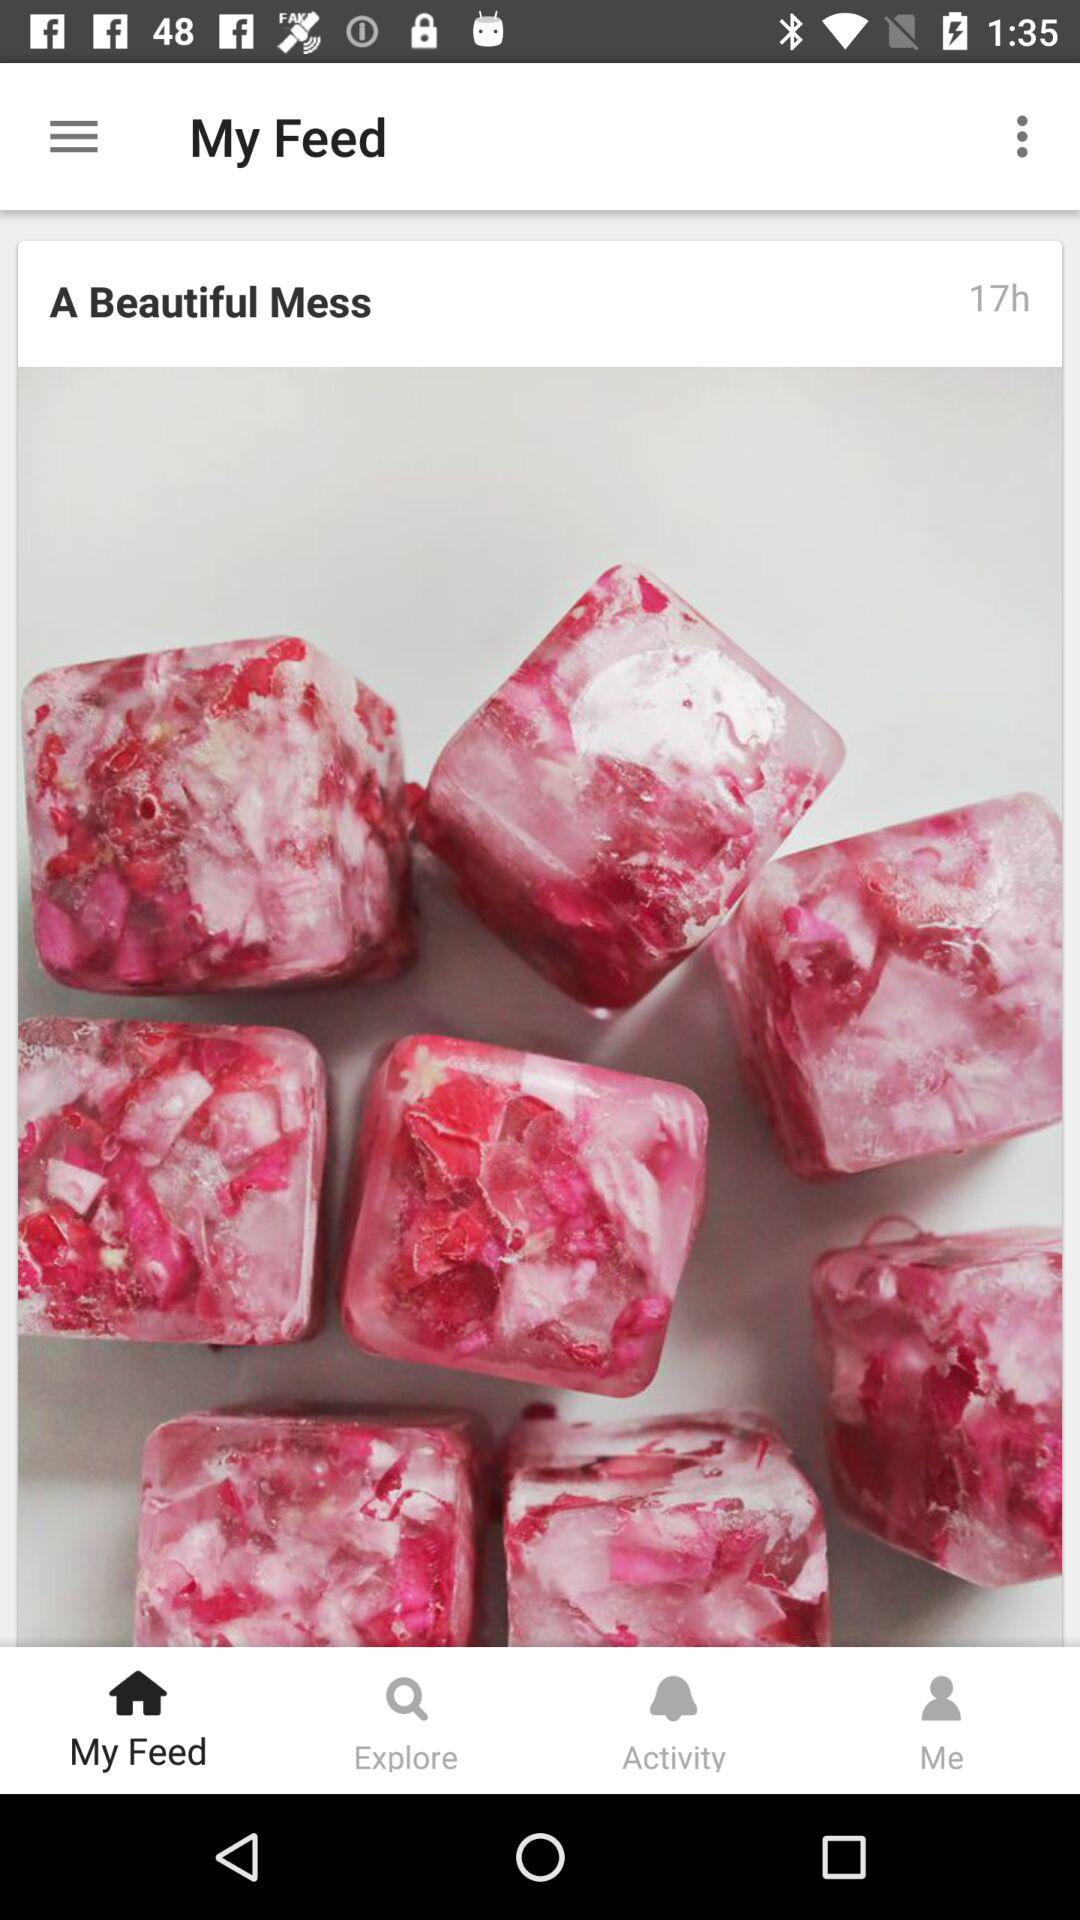How long ago was "A Beautiful Mess" posted? "A Beautiful Mess" was posted 17 hours ago. 